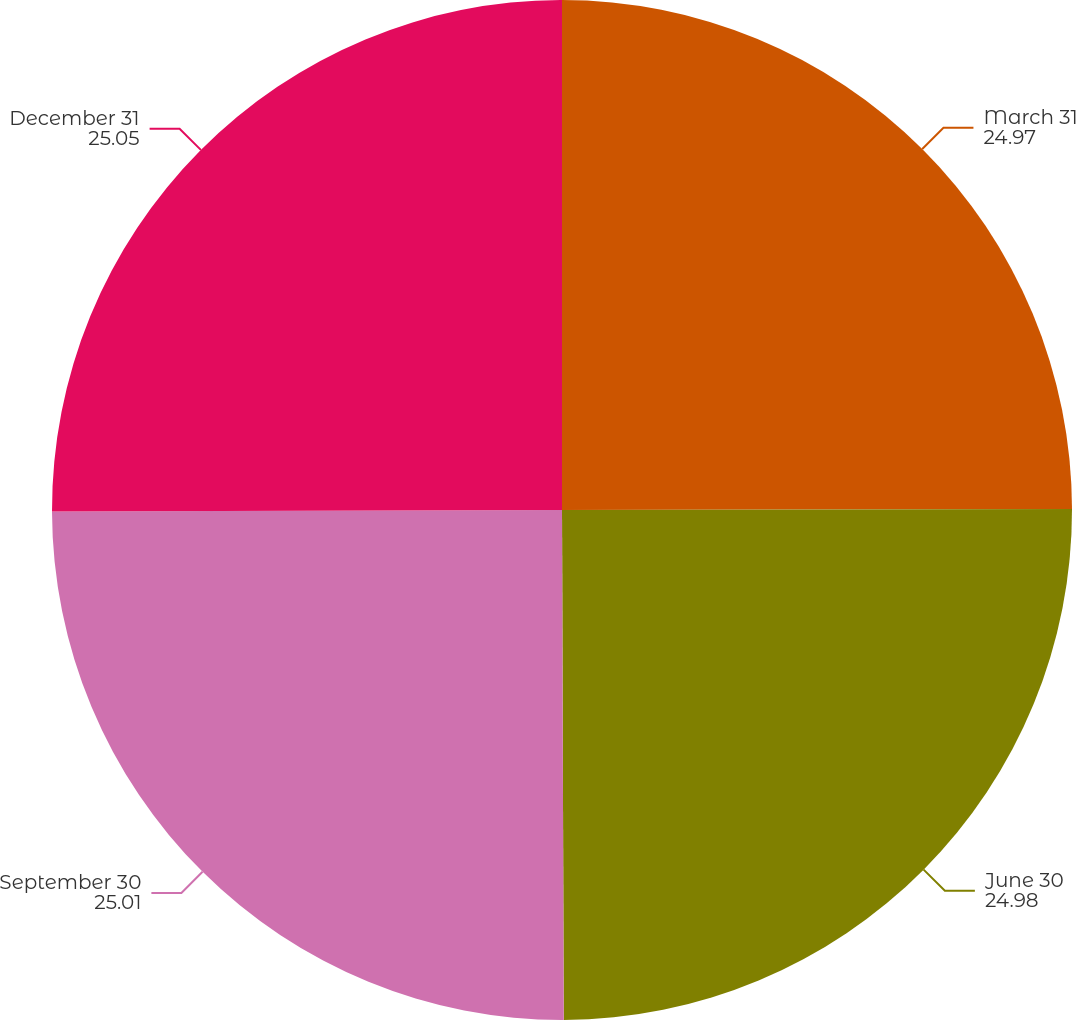Convert chart to OTSL. <chart><loc_0><loc_0><loc_500><loc_500><pie_chart><fcel>March 31<fcel>June 30<fcel>September 30<fcel>December 31<nl><fcel>24.97%<fcel>24.98%<fcel>25.01%<fcel>25.05%<nl></chart> 